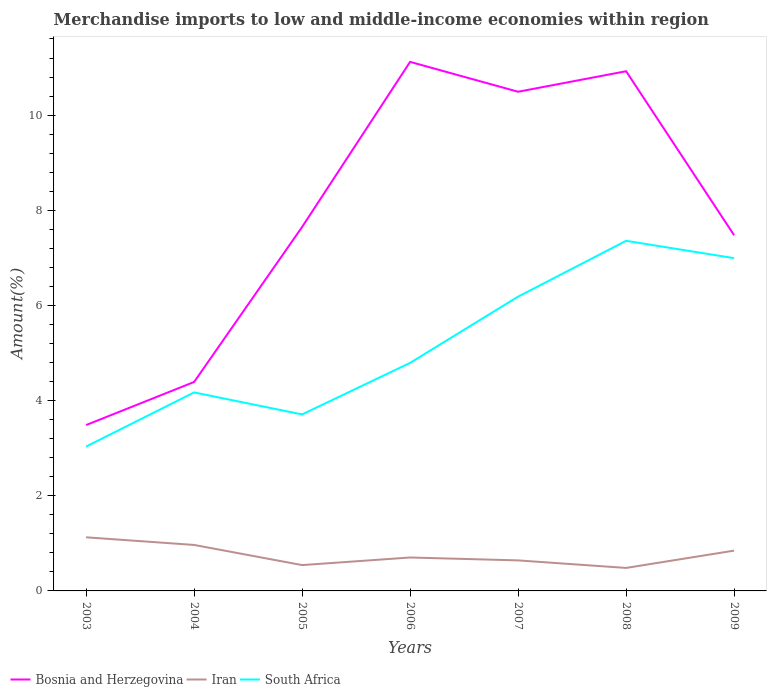Does the line corresponding to South Africa intersect with the line corresponding to Iran?
Your answer should be very brief. No. Is the number of lines equal to the number of legend labels?
Your answer should be very brief. Yes. Across all years, what is the maximum percentage of amount earned from merchandise imports in Iran?
Provide a short and direct response. 0.48. What is the total percentage of amount earned from merchandise imports in Iran in the graph?
Your answer should be very brief. -0.16. What is the difference between the highest and the second highest percentage of amount earned from merchandise imports in Iran?
Ensure brevity in your answer.  0.64. What is the difference between the highest and the lowest percentage of amount earned from merchandise imports in Iran?
Give a very brief answer. 3. How many years are there in the graph?
Ensure brevity in your answer.  7. Does the graph contain any zero values?
Make the answer very short. No. Does the graph contain grids?
Keep it short and to the point. No. Where does the legend appear in the graph?
Provide a succinct answer. Bottom left. How are the legend labels stacked?
Keep it short and to the point. Horizontal. What is the title of the graph?
Your answer should be compact. Merchandise imports to low and middle-income economies within region. What is the label or title of the Y-axis?
Provide a short and direct response. Amount(%). What is the Amount(%) of Bosnia and Herzegovina in 2003?
Your answer should be compact. 3.49. What is the Amount(%) of Iran in 2003?
Give a very brief answer. 1.13. What is the Amount(%) in South Africa in 2003?
Offer a very short reply. 3.03. What is the Amount(%) in Bosnia and Herzegovina in 2004?
Give a very brief answer. 4.39. What is the Amount(%) of Iran in 2004?
Offer a terse response. 0.97. What is the Amount(%) in South Africa in 2004?
Offer a very short reply. 4.17. What is the Amount(%) of Bosnia and Herzegovina in 2005?
Give a very brief answer. 7.65. What is the Amount(%) of Iran in 2005?
Provide a succinct answer. 0.54. What is the Amount(%) of South Africa in 2005?
Your answer should be very brief. 3.71. What is the Amount(%) in Bosnia and Herzegovina in 2006?
Offer a terse response. 11.12. What is the Amount(%) in Iran in 2006?
Your response must be concise. 0.7. What is the Amount(%) of South Africa in 2006?
Make the answer very short. 4.79. What is the Amount(%) of Bosnia and Herzegovina in 2007?
Provide a succinct answer. 10.49. What is the Amount(%) of Iran in 2007?
Your response must be concise. 0.64. What is the Amount(%) of South Africa in 2007?
Provide a short and direct response. 6.19. What is the Amount(%) in Bosnia and Herzegovina in 2008?
Keep it short and to the point. 10.92. What is the Amount(%) of Iran in 2008?
Your answer should be compact. 0.48. What is the Amount(%) in South Africa in 2008?
Ensure brevity in your answer.  7.36. What is the Amount(%) of Bosnia and Herzegovina in 2009?
Offer a very short reply. 7.48. What is the Amount(%) in Iran in 2009?
Keep it short and to the point. 0.85. What is the Amount(%) in South Africa in 2009?
Provide a succinct answer. 6.99. Across all years, what is the maximum Amount(%) in Bosnia and Herzegovina?
Ensure brevity in your answer.  11.12. Across all years, what is the maximum Amount(%) in Iran?
Offer a very short reply. 1.13. Across all years, what is the maximum Amount(%) of South Africa?
Keep it short and to the point. 7.36. Across all years, what is the minimum Amount(%) of Bosnia and Herzegovina?
Your response must be concise. 3.49. Across all years, what is the minimum Amount(%) in Iran?
Give a very brief answer. 0.48. Across all years, what is the minimum Amount(%) in South Africa?
Offer a very short reply. 3.03. What is the total Amount(%) of Bosnia and Herzegovina in the graph?
Make the answer very short. 55.54. What is the total Amount(%) of Iran in the graph?
Your answer should be very brief. 5.31. What is the total Amount(%) of South Africa in the graph?
Offer a terse response. 36.25. What is the difference between the Amount(%) of Bosnia and Herzegovina in 2003 and that in 2004?
Your answer should be compact. -0.91. What is the difference between the Amount(%) in Iran in 2003 and that in 2004?
Ensure brevity in your answer.  0.16. What is the difference between the Amount(%) of South Africa in 2003 and that in 2004?
Provide a succinct answer. -1.14. What is the difference between the Amount(%) in Bosnia and Herzegovina in 2003 and that in 2005?
Keep it short and to the point. -4.16. What is the difference between the Amount(%) in Iran in 2003 and that in 2005?
Give a very brief answer. 0.58. What is the difference between the Amount(%) of South Africa in 2003 and that in 2005?
Offer a very short reply. -0.68. What is the difference between the Amount(%) in Bosnia and Herzegovina in 2003 and that in 2006?
Offer a terse response. -7.63. What is the difference between the Amount(%) in Iran in 2003 and that in 2006?
Provide a short and direct response. 0.42. What is the difference between the Amount(%) of South Africa in 2003 and that in 2006?
Provide a short and direct response. -1.76. What is the difference between the Amount(%) of Bosnia and Herzegovina in 2003 and that in 2007?
Your response must be concise. -7.01. What is the difference between the Amount(%) in Iran in 2003 and that in 2007?
Provide a short and direct response. 0.49. What is the difference between the Amount(%) in South Africa in 2003 and that in 2007?
Provide a succinct answer. -3.15. What is the difference between the Amount(%) of Bosnia and Herzegovina in 2003 and that in 2008?
Your response must be concise. -7.44. What is the difference between the Amount(%) of Iran in 2003 and that in 2008?
Give a very brief answer. 0.64. What is the difference between the Amount(%) of South Africa in 2003 and that in 2008?
Keep it short and to the point. -4.32. What is the difference between the Amount(%) in Bosnia and Herzegovina in 2003 and that in 2009?
Offer a very short reply. -3.99. What is the difference between the Amount(%) in Iran in 2003 and that in 2009?
Your answer should be compact. 0.28. What is the difference between the Amount(%) in South Africa in 2003 and that in 2009?
Provide a short and direct response. -3.96. What is the difference between the Amount(%) in Bosnia and Herzegovina in 2004 and that in 2005?
Provide a succinct answer. -3.26. What is the difference between the Amount(%) of Iran in 2004 and that in 2005?
Keep it short and to the point. 0.42. What is the difference between the Amount(%) in South Africa in 2004 and that in 2005?
Offer a very short reply. 0.46. What is the difference between the Amount(%) of Bosnia and Herzegovina in 2004 and that in 2006?
Give a very brief answer. -6.73. What is the difference between the Amount(%) of Iran in 2004 and that in 2006?
Offer a very short reply. 0.26. What is the difference between the Amount(%) in South Africa in 2004 and that in 2006?
Keep it short and to the point. -0.62. What is the difference between the Amount(%) in Bosnia and Herzegovina in 2004 and that in 2007?
Your answer should be very brief. -6.1. What is the difference between the Amount(%) of Iran in 2004 and that in 2007?
Ensure brevity in your answer.  0.32. What is the difference between the Amount(%) in South Africa in 2004 and that in 2007?
Ensure brevity in your answer.  -2.01. What is the difference between the Amount(%) in Bosnia and Herzegovina in 2004 and that in 2008?
Ensure brevity in your answer.  -6.53. What is the difference between the Amount(%) of Iran in 2004 and that in 2008?
Offer a very short reply. 0.48. What is the difference between the Amount(%) in South Africa in 2004 and that in 2008?
Make the answer very short. -3.19. What is the difference between the Amount(%) in Bosnia and Herzegovina in 2004 and that in 2009?
Your response must be concise. -3.09. What is the difference between the Amount(%) of Iran in 2004 and that in 2009?
Ensure brevity in your answer.  0.12. What is the difference between the Amount(%) of South Africa in 2004 and that in 2009?
Provide a short and direct response. -2.82. What is the difference between the Amount(%) in Bosnia and Herzegovina in 2005 and that in 2006?
Offer a terse response. -3.47. What is the difference between the Amount(%) in Iran in 2005 and that in 2006?
Provide a short and direct response. -0.16. What is the difference between the Amount(%) in South Africa in 2005 and that in 2006?
Provide a succinct answer. -1.08. What is the difference between the Amount(%) of Bosnia and Herzegovina in 2005 and that in 2007?
Ensure brevity in your answer.  -2.84. What is the difference between the Amount(%) in Iran in 2005 and that in 2007?
Provide a short and direct response. -0.1. What is the difference between the Amount(%) in South Africa in 2005 and that in 2007?
Your answer should be compact. -2.48. What is the difference between the Amount(%) of Bosnia and Herzegovina in 2005 and that in 2008?
Offer a very short reply. -3.27. What is the difference between the Amount(%) in Iran in 2005 and that in 2008?
Keep it short and to the point. 0.06. What is the difference between the Amount(%) in South Africa in 2005 and that in 2008?
Provide a succinct answer. -3.65. What is the difference between the Amount(%) in Bosnia and Herzegovina in 2005 and that in 2009?
Your answer should be compact. 0.17. What is the difference between the Amount(%) in Iran in 2005 and that in 2009?
Your response must be concise. -0.3. What is the difference between the Amount(%) in South Africa in 2005 and that in 2009?
Offer a very short reply. -3.28. What is the difference between the Amount(%) of Bosnia and Herzegovina in 2006 and that in 2007?
Your answer should be very brief. 0.63. What is the difference between the Amount(%) in Iran in 2006 and that in 2007?
Give a very brief answer. 0.06. What is the difference between the Amount(%) in South Africa in 2006 and that in 2007?
Your answer should be compact. -1.39. What is the difference between the Amount(%) in Bosnia and Herzegovina in 2006 and that in 2008?
Your response must be concise. 0.2. What is the difference between the Amount(%) of Iran in 2006 and that in 2008?
Give a very brief answer. 0.22. What is the difference between the Amount(%) in South Africa in 2006 and that in 2008?
Make the answer very short. -2.57. What is the difference between the Amount(%) in Bosnia and Herzegovina in 2006 and that in 2009?
Offer a terse response. 3.64. What is the difference between the Amount(%) of Iran in 2006 and that in 2009?
Your answer should be compact. -0.14. What is the difference between the Amount(%) in South Africa in 2006 and that in 2009?
Your answer should be compact. -2.2. What is the difference between the Amount(%) in Bosnia and Herzegovina in 2007 and that in 2008?
Your response must be concise. -0.43. What is the difference between the Amount(%) in Iran in 2007 and that in 2008?
Ensure brevity in your answer.  0.16. What is the difference between the Amount(%) of South Africa in 2007 and that in 2008?
Keep it short and to the point. -1.17. What is the difference between the Amount(%) in Bosnia and Herzegovina in 2007 and that in 2009?
Make the answer very short. 3.01. What is the difference between the Amount(%) of Iran in 2007 and that in 2009?
Give a very brief answer. -0.21. What is the difference between the Amount(%) of South Africa in 2007 and that in 2009?
Your response must be concise. -0.81. What is the difference between the Amount(%) in Bosnia and Herzegovina in 2008 and that in 2009?
Provide a succinct answer. 3.45. What is the difference between the Amount(%) in Iran in 2008 and that in 2009?
Provide a short and direct response. -0.36. What is the difference between the Amount(%) of South Africa in 2008 and that in 2009?
Provide a succinct answer. 0.36. What is the difference between the Amount(%) in Bosnia and Herzegovina in 2003 and the Amount(%) in Iran in 2004?
Provide a short and direct response. 2.52. What is the difference between the Amount(%) in Bosnia and Herzegovina in 2003 and the Amount(%) in South Africa in 2004?
Your answer should be compact. -0.69. What is the difference between the Amount(%) in Iran in 2003 and the Amount(%) in South Africa in 2004?
Keep it short and to the point. -3.05. What is the difference between the Amount(%) in Bosnia and Herzegovina in 2003 and the Amount(%) in Iran in 2005?
Your answer should be very brief. 2.94. What is the difference between the Amount(%) of Bosnia and Herzegovina in 2003 and the Amount(%) of South Africa in 2005?
Your answer should be compact. -0.22. What is the difference between the Amount(%) of Iran in 2003 and the Amount(%) of South Africa in 2005?
Your answer should be very brief. -2.58. What is the difference between the Amount(%) of Bosnia and Herzegovina in 2003 and the Amount(%) of Iran in 2006?
Keep it short and to the point. 2.78. What is the difference between the Amount(%) in Bosnia and Herzegovina in 2003 and the Amount(%) in South Africa in 2006?
Your answer should be compact. -1.31. What is the difference between the Amount(%) of Iran in 2003 and the Amount(%) of South Africa in 2006?
Offer a very short reply. -3.67. What is the difference between the Amount(%) in Bosnia and Herzegovina in 2003 and the Amount(%) in Iran in 2007?
Your response must be concise. 2.84. What is the difference between the Amount(%) in Bosnia and Herzegovina in 2003 and the Amount(%) in South Africa in 2007?
Offer a terse response. -2.7. What is the difference between the Amount(%) in Iran in 2003 and the Amount(%) in South Africa in 2007?
Your answer should be compact. -5.06. What is the difference between the Amount(%) of Bosnia and Herzegovina in 2003 and the Amount(%) of Iran in 2008?
Your answer should be compact. 3. What is the difference between the Amount(%) of Bosnia and Herzegovina in 2003 and the Amount(%) of South Africa in 2008?
Give a very brief answer. -3.87. What is the difference between the Amount(%) of Iran in 2003 and the Amount(%) of South Africa in 2008?
Your answer should be compact. -6.23. What is the difference between the Amount(%) of Bosnia and Herzegovina in 2003 and the Amount(%) of Iran in 2009?
Your answer should be compact. 2.64. What is the difference between the Amount(%) of Bosnia and Herzegovina in 2003 and the Amount(%) of South Africa in 2009?
Make the answer very short. -3.51. What is the difference between the Amount(%) of Iran in 2003 and the Amount(%) of South Africa in 2009?
Provide a short and direct response. -5.87. What is the difference between the Amount(%) of Bosnia and Herzegovina in 2004 and the Amount(%) of Iran in 2005?
Offer a terse response. 3.85. What is the difference between the Amount(%) of Bosnia and Herzegovina in 2004 and the Amount(%) of South Africa in 2005?
Your answer should be very brief. 0.68. What is the difference between the Amount(%) in Iran in 2004 and the Amount(%) in South Africa in 2005?
Ensure brevity in your answer.  -2.74. What is the difference between the Amount(%) in Bosnia and Herzegovina in 2004 and the Amount(%) in Iran in 2006?
Provide a short and direct response. 3.69. What is the difference between the Amount(%) of Bosnia and Herzegovina in 2004 and the Amount(%) of South Africa in 2006?
Your response must be concise. -0.4. What is the difference between the Amount(%) in Iran in 2004 and the Amount(%) in South Africa in 2006?
Your answer should be compact. -3.83. What is the difference between the Amount(%) of Bosnia and Herzegovina in 2004 and the Amount(%) of Iran in 2007?
Your answer should be very brief. 3.75. What is the difference between the Amount(%) of Bosnia and Herzegovina in 2004 and the Amount(%) of South Africa in 2007?
Offer a very short reply. -1.79. What is the difference between the Amount(%) in Iran in 2004 and the Amount(%) in South Africa in 2007?
Provide a succinct answer. -5.22. What is the difference between the Amount(%) of Bosnia and Herzegovina in 2004 and the Amount(%) of Iran in 2008?
Offer a very short reply. 3.91. What is the difference between the Amount(%) of Bosnia and Herzegovina in 2004 and the Amount(%) of South Africa in 2008?
Offer a terse response. -2.97. What is the difference between the Amount(%) in Iran in 2004 and the Amount(%) in South Africa in 2008?
Provide a succinct answer. -6.39. What is the difference between the Amount(%) in Bosnia and Herzegovina in 2004 and the Amount(%) in Iran in 2009?
Offer a very short reply. 3.54. What is the difference between the Amount(%) in Bosnia and Herzegovina in 2004 and the Amount(%) in South Africa in 2009?
Offer a very short reply. -2.6. What is the difference between the Amount(%) in Iran in 2004 and the Amount(%) in South Africa in 2009?
Your answer should be very brief. -6.03. What is the difference between the Amount(%) in Bosnia and Herzegovina in 2005 and the Amount(%) in Iran in 2006?
Give a very brief answer. 6.95. What is the difference between the Amount(%) in Bosnia and Herzegovina in 2005 and the Amount(%) in South Africa in 2006?
Offer a terse response. 2.86. What is the difference between the Amount(%) in Iran in 2005 and the Amount(%) in South Africa in 2006?
Give a very brief answer. -4.25. What is the difference between the Amount(%) of Bosnia and Herzegovina in 2005 and the Amount(%) of Iran in 2007?
Your response must be concise. 7.01. What is the difference between the Amount(%) in Bosnia and Herzegovina in 2005 and the Amount(%) in South Africa in 2007?
Give a very brief answer. 1.46. What is the difference between the Amount(%) in Iran in 2005 and the Amount(%) in South Africa in 2007?
Keep it short and to the point. -5.64. What is the difference between the Amount(%) in Bosnia and Herzegovina in 2005 and the Amount(%) in Iran in 2008?
Offer a terse response. 7.17. What is the difference between the Amount(%) in Bosnia and Herzegovina in 2005 and the Amount(%) in South Africa in 2008?
Ensure brevity in your answer.  0.29. What is the difference between the Amount(%) of Iran in 2005 and the Amount(%) of South Africa in 2008?
Make the answer very short. -6.82. What is the difference between the Amount(%) in Bosnia and Herzegovina in 2005 and the Amount(%) in Iran in 2009?
Offer a very short reply. 6.8. What is the difference between the Amount(%) in Bosnia and Herzegovina in 2005 and the Amount(%) in South Africa in 2009?
Your answer should be compact. 0.65. What is the difference between the Amount(%) in Iran in 2005 and the Amount(%) in South Africa in 2009?
Provide a succinct answer. -6.45. What is the difference between the Amount(%) in Bosnia and Herzegovina in 2006 and the Amount(%) in Iran in 2007?
Offer a terse response. 10.48. What is the difference between the Amount(%) in Bosnia and Herzegovina in 2006 and the Amount(%) in South Africa in 2007?
Give a very brief answer. 4.93. What is the difference between the Amount(%) in Iran in 2006 and the Amount(%) in South Africa in 2007?
Provide a succinct answer. -5.48. What is the difference between the Amount(%) of Bosnia and Herzegovina in 2006 and the Amount(%) of Iran in 2008?
Provide a succinct answer. 10.64. What is the difference between the Amount(%) in Bosnia and Herzegovina in 2006 and the Amount(%) in South Africa in 2008?
Offer a terse response. 3.76. What is the difference between the Amount(%) of Iran in 2006 and the Amount(%) of South Africa in 2008?
Your response must be concise. -6.66. What is the difference between the Amount(%) of Bosnia and Herzegovina in 2006 and the Amount(%) of Iran in 2009?
Offer a very short reply. 10.27. What is the difference between the Amount(%) of Bosnia and Herzegovina in 2006 and the Amount(%) of South Africa in 2009?
Your response must be concise. 4.12. What is the difference between the Amount(%) in Iran in 2006 and the Amount(%) in South Africa in 2009?
Ensure brevity in your answer.  -6.29. What is the difference between the Amount(%) in Bosnia and Herzegovina in 2007 and the Amount(%) in Iran in 2008?
Provide a succinct answer. 10.01. What is the difference between the Amount(%) of Bosnia and Herzegovina in 2007 and the Amount(%) of South Africa in 2008?
Your answer should be very brief. 3.13. What is the difference between the Amount(%) in Iran in 2007 and the Amount(%) in South Africa in 2008?
Your answer should be very brief. -6.72. What is the difference between the Amount(%) in Bosnia and Herzegovina in 2007 and the Amount(%) in Iran in 2009?
Keep it short and to the point. 9.64. What is the difference between the Amount(%) of Bosnia and Herzegovina in 2007 and the Amount(%) of South Africa in 2009?
Offer a terse response. 3.5. What is the difference between the Amount(%) of Iran in 2007 and the Amount(%) of South Africa in 2009?
Give a very brief answer. -6.35. What is the difference between the Amount(%) of Bosnia and Herzegovina in 2008 and the Amount(%) of Iran in 2009?
Your response must be concise. 10.08. What is the difference between the Amount(%) of Bosnia and Herzegovina in 2008 and the Amount(%) of South Africa in 2009?
Keep it short and to the point. 3.93. What is the difference between the Amount(%) of Iran in 2008 and the Amount(%) of South Africa in 2009?
Make the answer very short. -6.51. What is the average Amount(%) in Bosnia and Herzegovina per year?
Provide a short and direct response. 7.93. What is the average Amount(%) in Iran per year?
Provide a short and direct response. 0.76. What is the average Amount(%) in South Africa per year?
Your response must be concise. 5.18. In the year 2003, what is the difference between the Amount(%) in Bosnia and Herzegovina and Amount(%) in Iran?
Ensure brevity in your answer.  2.36. In the year 2003, what is the difference between the Amount(%) of Bosnia and Herzegovina and Amount(%) of South Africa?
Your answer should be compact. 0.45. In the year 2003, what is the difference between the Amount(%) in Iran and Amount(%) in South Africa?
Give a very brief answer. -1.91. In the year 2004, what is the difference between the Amount(%) of Bosnia and Herzegovina and Amount(%) of Iran?
Offer a terse response. 3.43. In the year 2004, what is the difference between the Amount(%) of Bosnia and Herzegovina and Amount(%) of South Africa?
Offer a terse response. 0.22. In the year 2004, what is the difference between the Amount(%) in Iran and Amount(%) in South Africa?
Your answer should be compact. -3.21. In the year 2005, what is the difference between the Amount(%) in Bosnia and Herzegovina and Amount(%) in Iran?
Offer a terse response. 7.11. In the year 2005, what is the difference between the Amount(%) in Bosnia and Herzegovina and Amount(%) in South Africa?
Your response must be concise. 3.94. In the year 2005, what is the difference between the Amount(%) in Iran and Amount(%) in South Africa?
Your answer should be very brief. -3.17. In the year 2006, what is the difference between the Amount(%) in Bosnia and Herzegovina and Amount(%) in Iran?
Your response must be concise. 10.42. In the year 2006, what is the difference between the Amount(%) in Bosnia and Herzegovina and Amount(%) in South Africa?
Keep it short and to the point. 6.33. In the year 2006, what is the difference between the Amount(%) in Iran and Amount(%) in South Africa?
Make the answer very short. -4.09. In the year 2007, what is the difference between the Amount(%) in Bosnia and Herzegovina and Amount(%) in Iran?
Offer a terse response. 9.85. In the year 2007, what is the difference between the Amount(%) in Bosnia and Herzegovina and Amount(%) in South Africa?
Provide a succinct answer. 4.31. In the year 2007, what is the difference between the Amount(%) of Iran and Amount(%) of South Africa?
Ensure brevity in your answer.  -5.54. In the year 2008, what is the difference between the Amount(%) of Bosnia and Herzegovina and Amount(%) of Iran?
Your response must be concise. 10.44. In the year 2008, what is the difference between the Amount(%) of Bosnia and Herzegovina and Amount(%) of South Africa?
Your answer should be very brief. 3.56. In the year 2008, what is the difference between the Amount(%) in Iran and Amount(%) in South Africa?
Ensure brevity in your answer.  -6.87. In the year 2009, what is the difference between the Amount(%) of Bosnia and Herzegovina and Amount(%) of Iran?
Keep it short and to the point. 6.63. In the year 2009, what is the difference between the Amount(%) in Bosnia and Herzegovina and Amount(%) in South Africa?
Your answer should be compact. 0.48. In the year 2009, what is the difference between the Amount(%) of Iran and Amount(%) of South Africa?
Make the answer very short. -6.15. What is the ratio of the Amount(%) of Bosnia and Herzegovina in 2003 to that in 2004?
Your answer should be very brief. 0.79. What is the ratio of the Amount(%) in Iran in 2003 to that in 2004?
Keep it short and to the point. 1.17. What is the ratio of the Amount(%) in South Africa in 2003 to that in 2004?
Offer a very short reply. 0.73. What is the ratio of the Amount(%) of Bosnia and Herzegovina in 2003 to that in 2005?
Your response must be concise. 0.46. What is the ratio of the Amount(%) of Iran in 2003 to that in 2005?
Your answer should be compact. 2.08. What is the ratio of the Amount(%) of South Africa in 2003 to that in 2005?
Offer a terse response. 0.82. What is the ratio of the Amount(%) of Bosnia and Herzegovina in 2003 to that in 2006?
Provide a short and direct response. 0.31. What is the ratio of the Amount(%) in Iran in 2003 to that in 2006?
Give a very brief answer. 1.6. What is the ratio of the Amount(%) in South Africa in 2003 to that in 2006?
Offer a terse response. 0.63. What is the ratio of the Amount(%) of Bosnia and Herzegovina in 2003 to that in 2007?
Offer a terse response. 0.33. What is the ratio of the Amount(%) in Iran in 2003 to that in 2007?
Keep it short and to the point. 1.76. What is the ratio of the Amount(%) of South Africa in 2003 to that in 2007?
Provide a succinct answer. 0.49. What is the ratio of the Amount(%) in Bosnia and Herzegovina in 2003 to that in 2008?
Make the answer very short. 0.32. What is the ratio of the Amount(%) in Iran in 2003 to that in 2008?
Your response must be concise. 2.33. What is the ratio of the Amount(%) in South Africa in 2003 to that in 2008?
Your answer should be very brief. 0.41. What is the ratio of the Amount(%) in Bosnia and Herzegovina in 2003 to that in 2009?
Your response must be concise. 0.47. What is the ratio of the Amount(%) in Iran in 2003 to that in 2009?
Your answer should be compact. 1.33. What is the ratio of the Amount(%) in South Africa in 2003 to that in 2009?
Your answer should be very brief. 0.43. What is the ratio of the Amount(%) of Bosnia and Herzegovina in 2004 to that in 2005?
Ensure brevity in your answer.  0.57. What is the ratio of the Amount(%) in Iran in 2004 to that in 2005?
Your answer should be compact. 1.78. What is the ratio of the Amount(%) in South Africa in 2004 to that in 2005?
Offer a terse response. 1.12. What is the ratio of the Amount(%) of Bosnia and Herzegovina in 2004 to that in 2006?
Your answer should be compact. 0.4. What is the ratio of the Amount(%) in Iran in 2004 to that in 2006?
Provide a short and direct response. 1.38. What is the ratio of the Amount(%) of South Africa in 2004 to that in 2006?
Offer a very short reply. 0.87. What is the ratio of the Amount(%) in Bosnia and Herzegovina in 2004 to that in 2007?
Your answer should be compact. 0.42. What is the ratio of the Amount(%) of Iran in 2004 to that in 2007?
Offer a terse response. 1.51. What is the ratio of the Amount(%) of South Africa in 2004 to that in 2007?
Provide a short and direct response. 0.67. What is the ratio of the Amount(%) in Bosnia and Herzegovina in 2004 to that in 2008?
Your answer should be very brief. 0.4. What is the ratio of the Amount(%) in Iran in 2004 to that in 2008?
Give a very brief answer. 2. What is the ratio of the Amount(%) of South Africa in 2004 to that in 2008?
Provide a succinct answer. 0.57. What is the ratio of the Amount(%) of Bosnia and Herzegovina in 2004 to that in 2009?
Give a very brief answer. 0.59. What is the ratio of the Amount(%) of Iran in 2004 to that in 2009?
Your response must be concise. 1.14. What is the ratio of the Amount(%) in South Africa in 2004 to that in 2009?
Your answer should be very brief. 0.6. What is the ratio of the Amount(%) of Bosnia and Herzegovina in 2005 to that in 2006?
Give a very brief answer. 0.69. What is the ratio of the Amount(%) in Iran in 2005 to that in 2006?
Offer a very short reply. 0.77. What is the ratio of the Amount(%) in South Africa in 2005 to that in 2006?
Your response must be concise. 0.77. What is the ratio of the Amount(%) of Bosnia and Herzegovina in 2005 to that in 2007?
Your answer should be compact. 0.73. What is the ratio of the Amount(%) of Iran in 2005 to that in 2007?
Your response must be concise. 0.85. What is the ratio of the Amount(%) of South Africa in 2005 to that in 2007?
Your answer should be very brief. 0.6. What is the ratio of the Amount(%) of Bosnia and Herzegovina in 2005 to that in 2008?
Provide a short and direct response. 0.7. What is the ratio of the Amount(%) in Iran in 2005 to that in 2008?
Offer a very short reply. 1.12. What is the ratio of the Amount(%) of South Africa in 2005 to that in 2008?
Make the answer very short. 0.5. What is the ratio of the Amount(%) of Bosnia and Herzegovina in 2005 to that in 2009?
Give a very brief answer. 1.02. What is the ratio of the Amount(%) of Iran in 2005 to that in 2009?
Offer a very short reply. 0.64. What is the ratio of the Amount(%) in South Africa in 2005 to that in 2009?
Ensure brevity in your answer.  0.53. What is the ratio of the Amount(%) of Bosnia and Herzegovina in 2006 to that in 2007?
Provide a short and direct response. 1.06. What is the ratio of the Amount(%) in Iran in 2006 to that in 2007?
Make the answer very short. 1.1. What is the ratio of the Amount(%) of South Africa in 2006 to that in 2007?
Provide a short and direct response. 0.77. What is the ratio of the Amount(%) in Bosnia and Herzegovina in 2006 to that in 2008?
Provide a succinct answer. 1.02. What is the ratio of the Amount(%) in Iran in 2006 to that in 2008?
Your response must be concise. 1.45. What is the ratio of the Amount(%) of South Africa in 2006 to that in 2008?
Make the answer very short. 0.65. What is the ratio of the Amount(%) of Bosnia and Herzegovina in 2006 to that in 2009?
Your response must be concise. 1.49. What is the ratio of the Amount(%) of Iran in 2006 to that in 2009?
Ensure brevity in your answer.  0.83. What is the ratio of the Amount(%) in South Africa in 2006 to that in 2009?
Provide a succinct answer. 0.69. What is the ratio of the Amount(%) in Bosnia and Herzegovina in 2007 to that in 2008?
Your answer should be compact. 0.96. What is the ratio of the Amount(%) in Iran in 2007 to that in 2008?
Provide a succinct answer. 1.33. What is the ratio of the Amount(%) in South Africa in 2007 to that in 2008?
Your response must be concise. 0.84. What is the ratio of the Amount(%) in Bosnia and Herzegovina in 2007 to that in 2009?
Your response must be concise. 1.4. What is the ratio of the Amount(%) in Iran in 2007 to that in 2009?
Make the answer very short. 0.76. What is the ratio of the Amount(%) in South Africa in 2007 to that in 2009?
Make the answer very short. 0.88. What is the ratio of the Amount(%) in Bosnia and Herzegovina in 2008 to that in 2009?
Keep it short and to the point. 1.46. What is the ratio of the Amount(%) of Iran in 2008 to that in 2009?
Make the answer very short. 0.57. What is the ratio of the Amount(%) of South Africa in 2008 to that in 2009?
Your answer should be very brief. 1.05. What is the difference between the highest and the second highest Amount(%) of Bosnia and Herzegovina?
Offer a very short reply. 0.2. What is the difference between the highest and the second highest Amount(%) of Iran?
Your answer should be compact. 0.16. What is the difference between the highest and the second highest Amount(%) in South Africa?
Your answer should be very brief. 0.36. What is the difference between the highest and the lowest Amount(%) in Bosnia and Herzegovina?
Your answer should be very brief. 7.63. What is the difference between the highest and the lowest Amount(%) of Iran?
Make the answer very short. 0.64. What is the difference between the highest and the lowest Amount(%) of South Africa?
Provide a short and direct response. 4.32. 